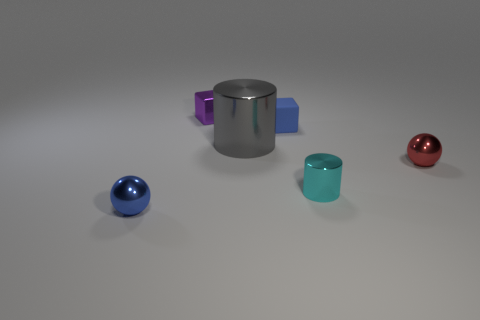Add 1 rubber things. How many objects exist? 7 Subtract all cubes. How many objects are left? 4 Subtract 0 cyan cubes. How many objects are left? 6 Subtract all green cylinders. Subtract all cyan spheres. How many cylinders are left? 2 Subtract all purple cubes. Subtract all metal cylinders. How many objects are left? 3 Add 2 large metallic objects. How many large metallic objects are left? 3 Add 3 gray objects. How many gray objects exist? 4 